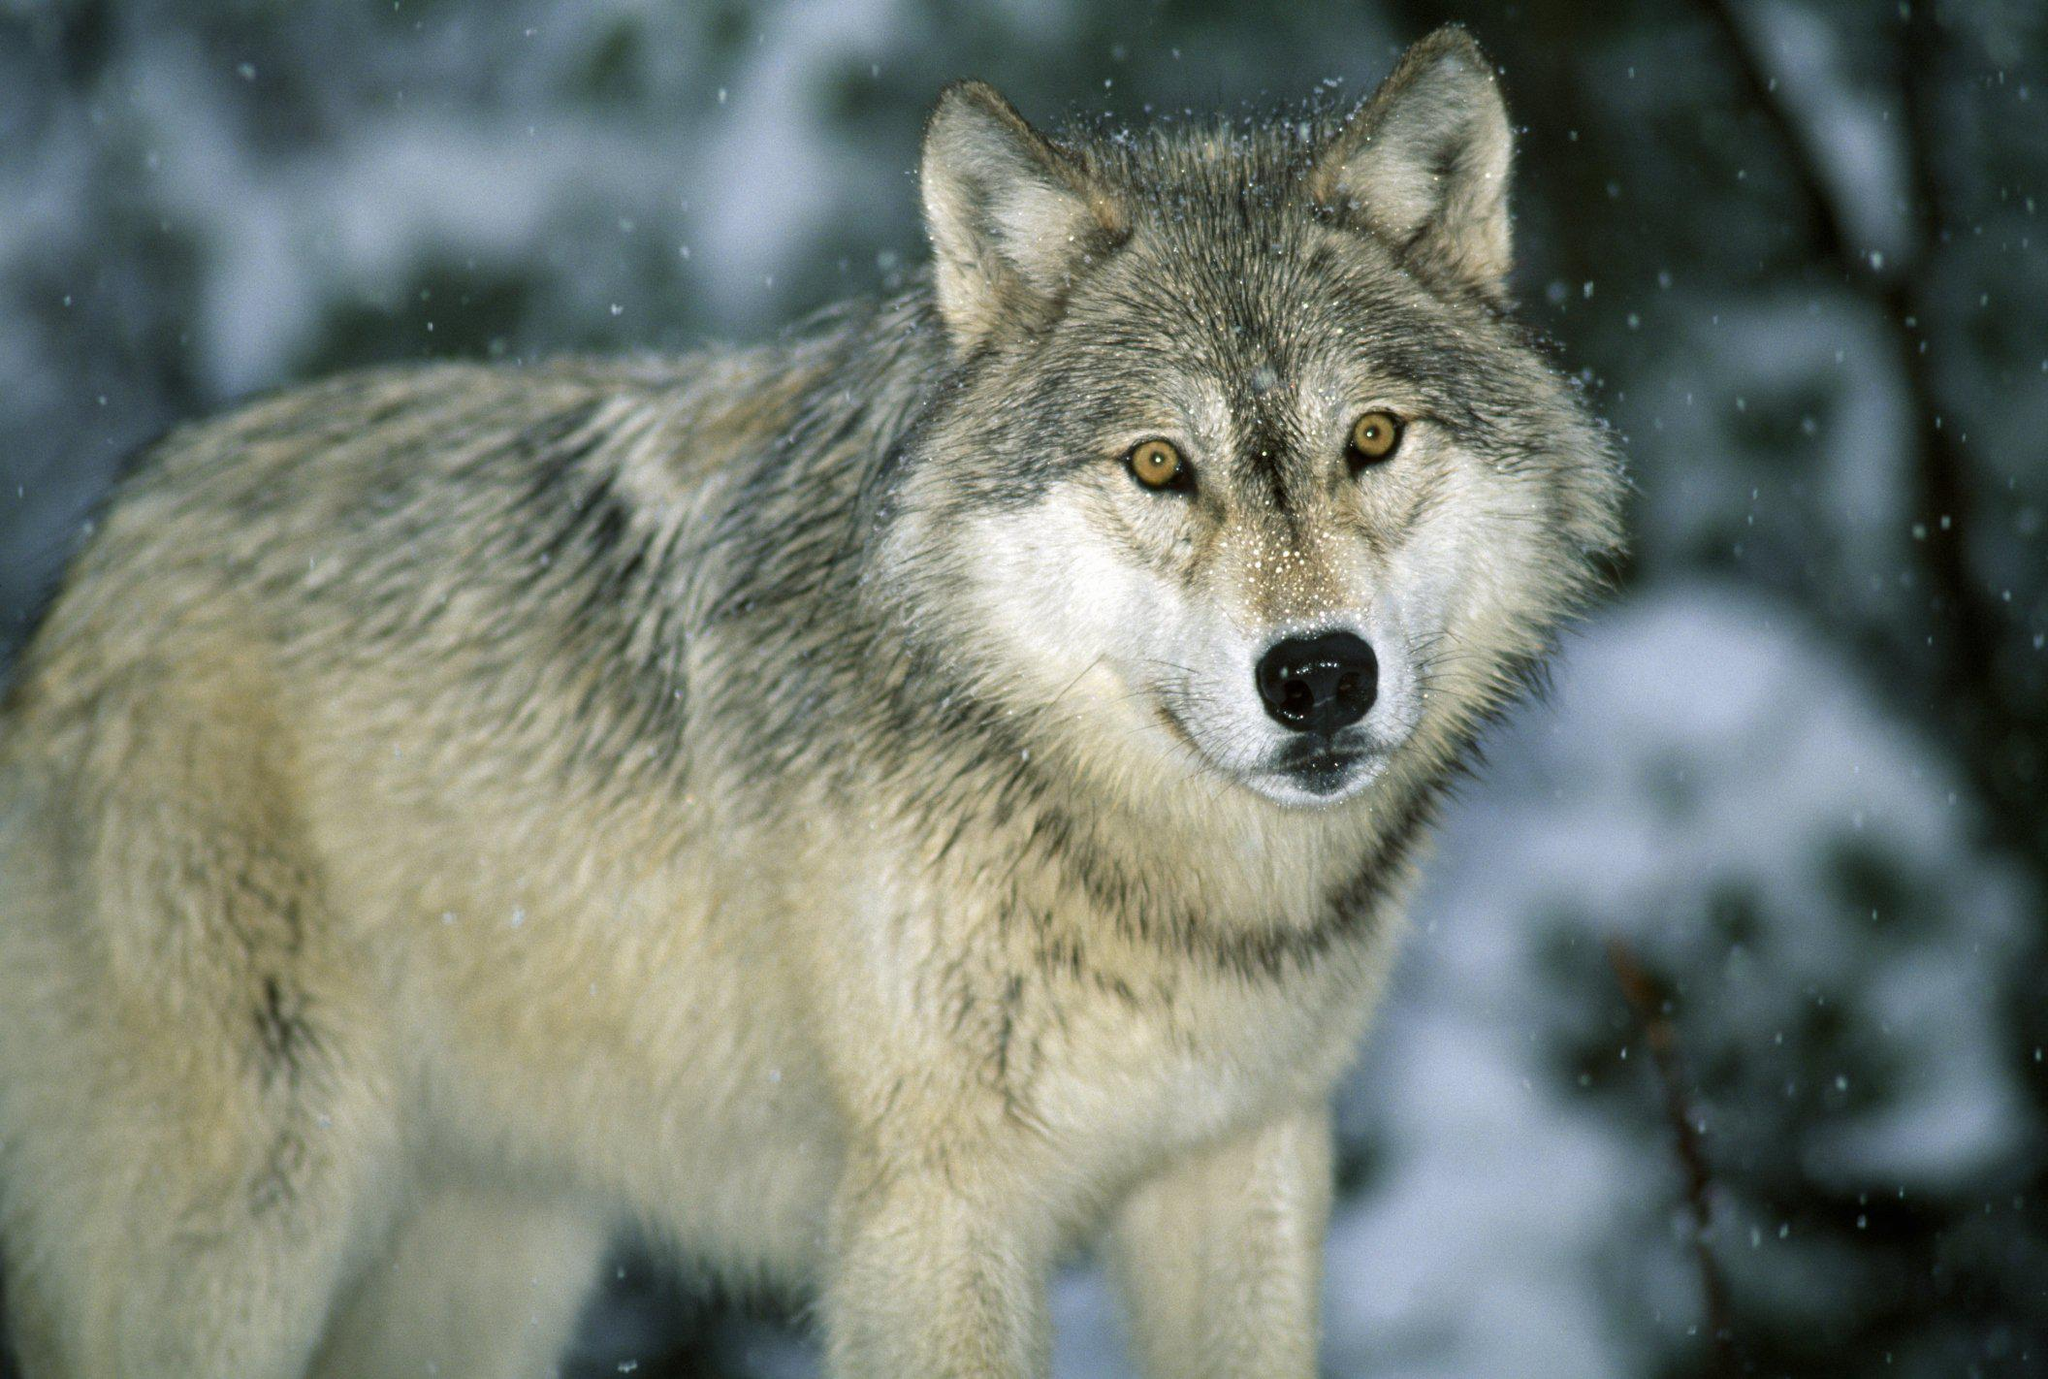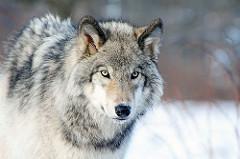The first image is the image on the left, the second image is the image on the right. Assess this claim about the two images: "The wolves are looking toward the camera.". Correct or not? Answer yes or no. Yes. The first image is the image on the left, the second image is the image on the right. For the images shown, is this caption "the wolves in the image pair are looking into the camera" true? Answer yes or no. Yes. 